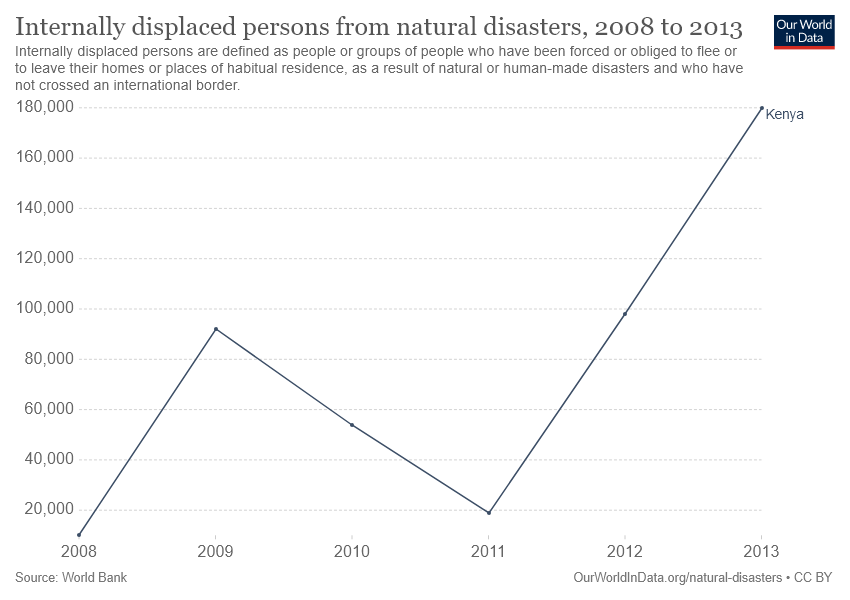List a handful of essential elements in this visual. In 2013, the highest number of people were displaced as a result of natural disasters in Kenya. According to the information provided, the years 2008 and 2011 recorded the least number of people displaced from natural disasters in Kenya. 